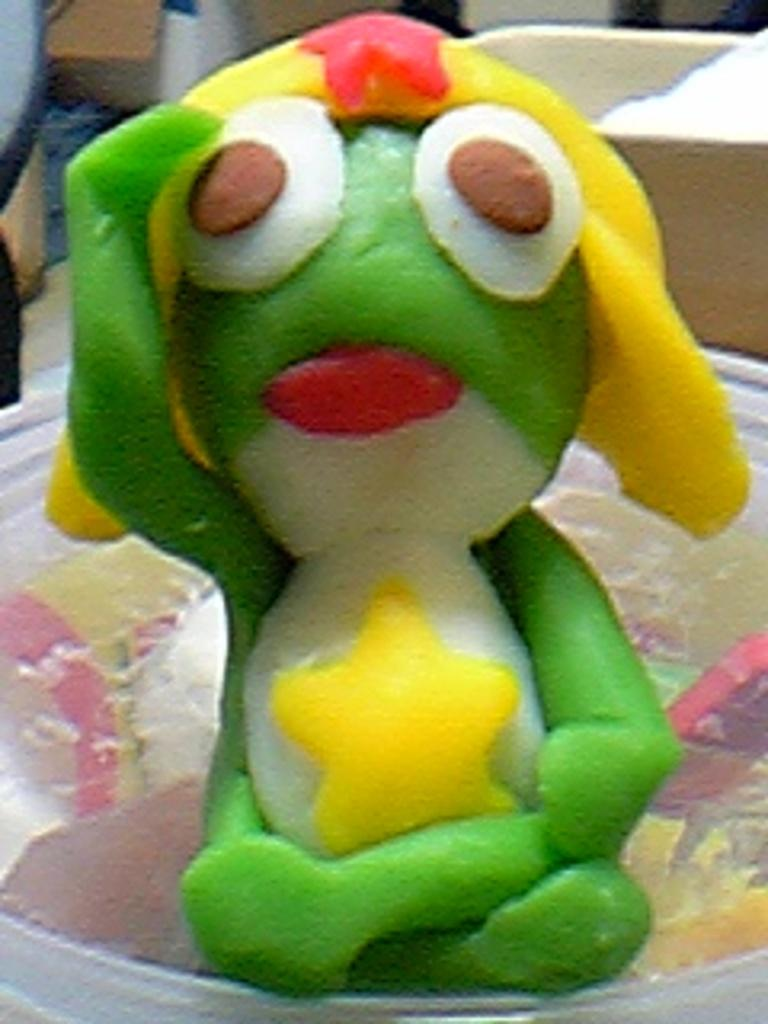What is the main object in the image? There is a toy in the image. Where is the toy located? The toy is placed on a surface. What can be seen behind the toy? There are objects visible behind the toy. What type of fear can be seen on the toy's face in the image? There is no indication of fear on the toy's face in the image, as toys typically do not have facial expressions. Is there any snow visible in the image? There is no mention of snow in the provided facts, and therefore it cannot be determined if snow is present in the image. 